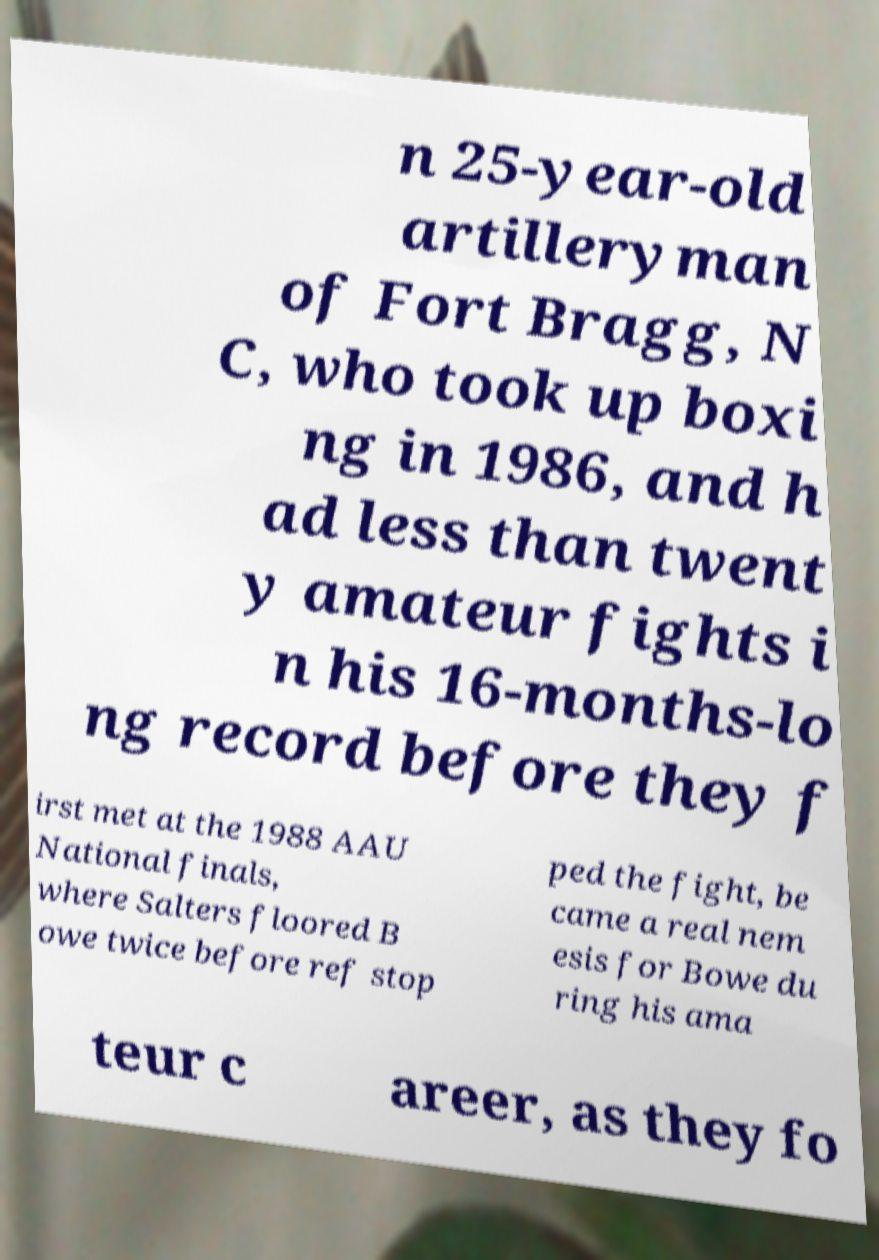Could you extract and type out the text from this image? n 25-year-old artilleryman of Fort Bragg, N C, who took up boxi ng in 1986, and h ad less than twent y amateur fights i n his 16-months-lo ng record before they f irst met at the 1988 AAU National finals, where Salters floored B owe twice before ref stop ped the fight, be came a real nem esis for Bowe du ring his ama teur c areer, as they fo 